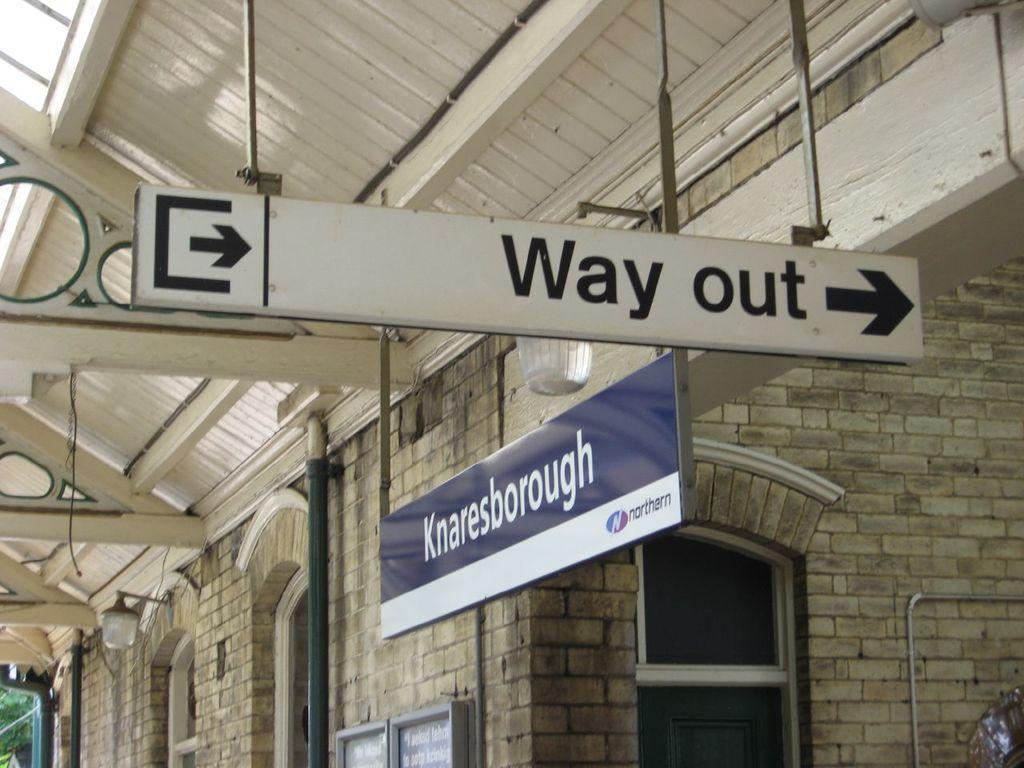Can you describe this image briefly? In this picture I can see boards, windows, iron rods, lights, this is looking like a building. 